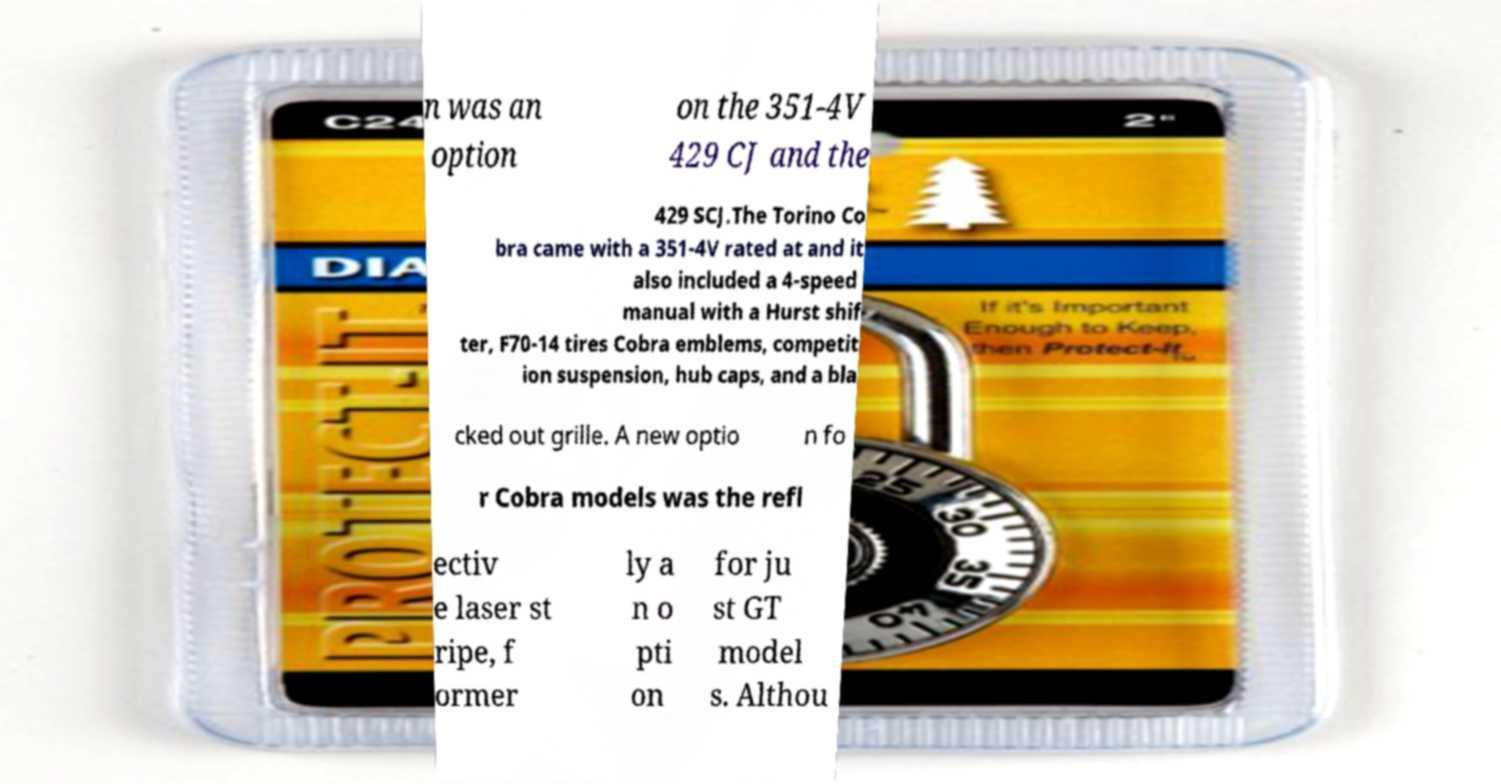Can you accurately transcribe the text from the provided image for me? n was an option on the 351-4V 429 CJ and the 429 SCJ.The Torino Co bra came with a 351-4V rated at and it also included a 4-speed manual with a Hurst shif ter, F70-14 tires Cobra emblems, competit ion suspension, hub caps, and a bla cked out grille. A new optio n fo r Cobra models was the refl ectiv e laser st ripe, f ormer ly a n o pti on for ju st GT model s. Althou 